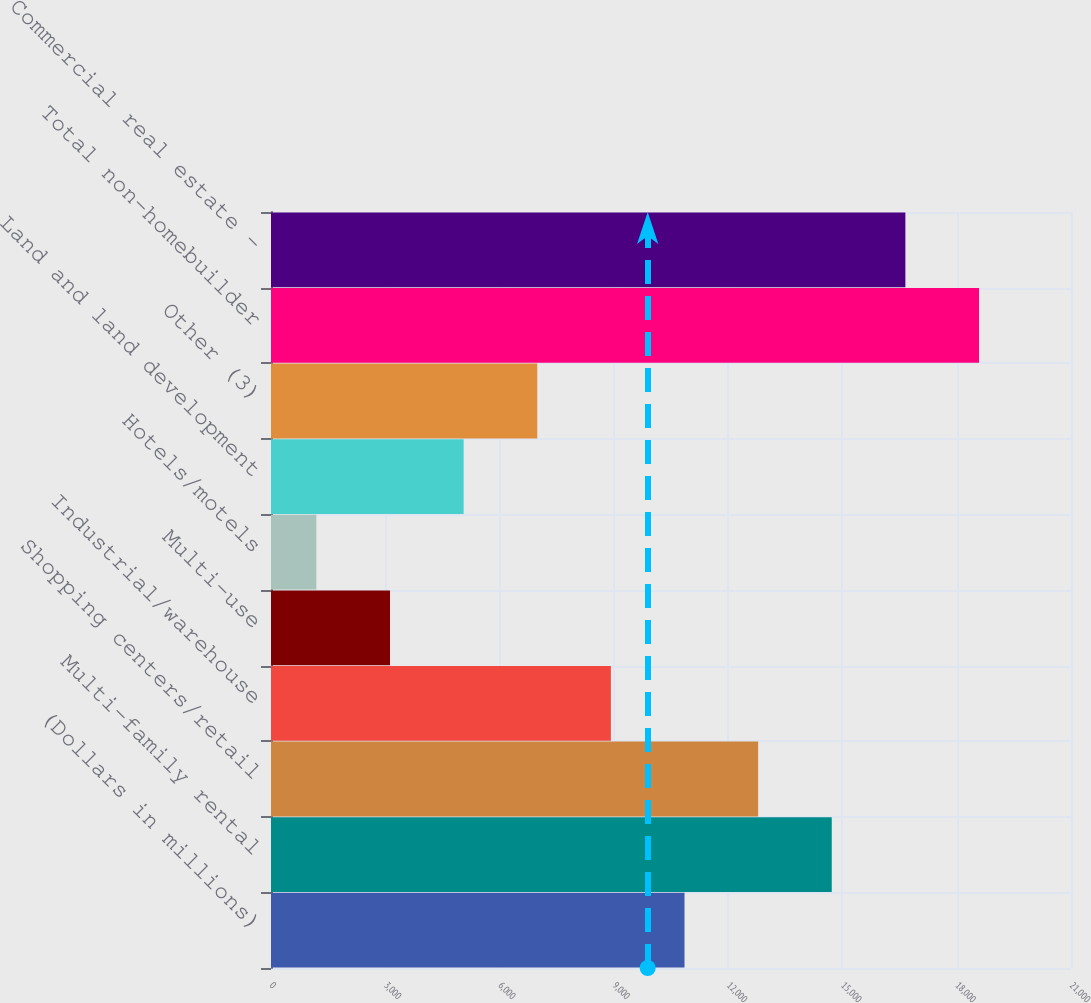Convert chart to OTSL. <chart><loc_0><loc_0><loc_500><loc_500><bar_chart><fcel>(Dollars in millions)<fcel>Multi-family rental<fcel>Shopping centers/retail<fcel>Industrial/warehouse<fcel>Multi-use<fcel>Hotels/motels<fcel>Land and land development<fcel>Other (3)<fcel>Total non-homebuilder<fcel>Commercial real estate -<nl><fcel>10854.5<fcel>14719.9<fcel>12787.2<fcel>8921.8<fcel>3123.7<fcel>1191<fcel>5056.4<fcel>6989.1<fcel>18585.3<fcel>16652.6<nl></chart> 